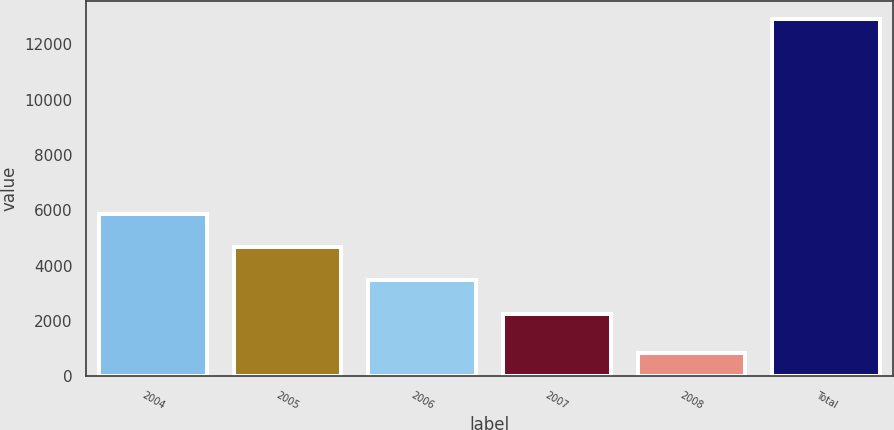<chart> <loc_0><loc_0><loc_500><loc_500><bar_chart><fcel>2004<fcel>2005<fcel>2006<fcel>2007<fcel>2008<fcel>Total<nl><fcel>5882.9<fcel>4676.6<fcel>3470.3<fcel>2264<fcel>863<fcel>12926<nl></chart> 